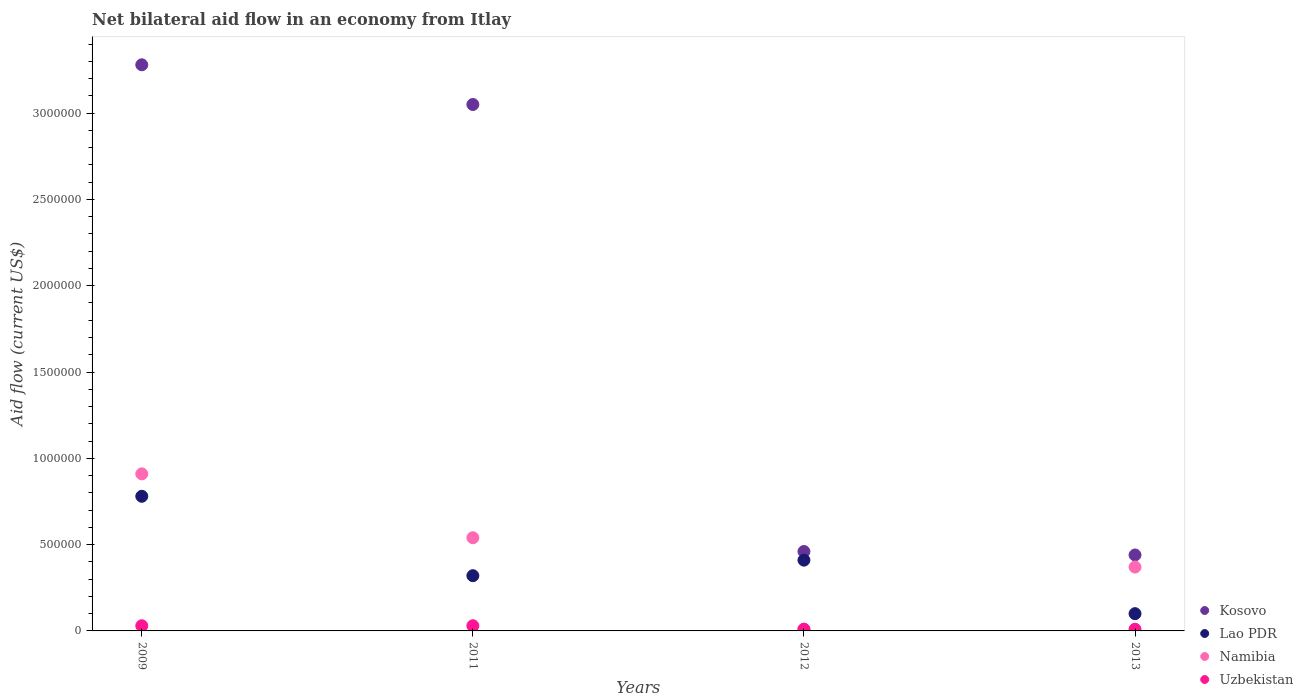How many different coloured dotlines are there?
Make the answer very short. 4. What is the net bilateral aid flow in Kosovo in 2011?
Your answer should be compact. 3.05e+06. Across all years, what is the maximum net bilateral aid flow in Namibia?
Give a very brief answer. 9.10e+05. Across all years, what is the minimum net bilateral aid flow in Namibia?
Provide a short and direct response. 10000. What is the total net bilateral aid flow in Lao PDR in the graph?
Make the answer very short. 1.61e+06. What is the difference between the net bilateral aid flow in Uzbekistan in 2009 and that in 2011?
Offer a very short reply. 0. What is the average net bilateral aid flow in Kosovo per year?
Provide a succinct answer. 1.81e+06. In the year 2013, what is the difference between the net bilateral aid flow in Lao PDR and net bilateral aid flow in Kosovo?
Offer a very short reply. -3.40e+05. What is the ratio of the net bilateral aid flow in Lao PDR in 2009 to that in 2013?
Your answer should be very brief. 7.8. What is the difference between the highest and the second highest net bilateral aid flow in Lao PDR?
Provide a succinct answer. 3.70e+05. What is the difference between the highest and the lowest net bilateral aid flow in Lao PDR?
Ensure brevity in your answer.  6.80e+05. In how many years, is the net bilateral aid flow in Kosovo greater than the average net bilateral aid flow in Kosovo taken over all years?
Make the answer very short. 2. Is the sum of the net bilateral aid flow in Lao PDR in 2011 and 2012 greater than the maximum net bilateral aid flow in Kosovo across all years?
Give a very brief answer. No. Is it the case that in every year, the sum of the net bilateral aid flow in Uzbekistan and net bilateral aid flow in Kosovo  is greater than the net bilateral aid flow in Namibia?
Offer a very short reply. Yes. Is the net bilateral aid flow in Namibia strictly greater than the net bilateral aid flow in Kosovo over the years?
Your answer should be very brief. No. Is the net bilateral aid flow in Kosovo strictly less than the net bilateral aid flow in Uzbekistan over the years?
Your answer should be compact. No. What is the difference between two consecutive major ticks on the Y-axis?
Your answer should be compact. 5.00e+05. Does the graph contain grids?
Ensure brevity in your answer.  No. What is the title of the graph?
Your answer should be very brief. Net bilateral aid flow in an economy from Itlay. Does "Qatar" appear as one of the legend labels in the graph?
Your answer should be compact. No. What is the label or title of the X-axis?
Offer a very short reply. Years. What is the label or title of the Y-axis?
Provide a succinct answer. Aid flow (current US$). What is the Aid flow (current US$) in Kosovo in 2009?
Your response must be concise. 3.28e+06. What is the Aid flow (current US$) of Lao PDR in 2009?
Offer a terse response. 7.80e+05. What is the Aid flow (current US$) of Namibia in 2009?
Provide a short and direct response. 9.10e+05. What is the Aid flow (current US$) of Kosovo in 2011?
Make the answer very short. 3.05e+06. What is the Aid flow (current US$) in Namibia in 2011?
Make the answer very short. 5.40e+05. What is the Aid flow (current US$) of Kosovo in 2012?
Give a very brief answer. 4.60e+05. What is the Aid flow (current US$) in Lao PDR in 2013?
Your answer should be compact. 1.00e+05. What is the Aid flow (current US$) in Namibia in 2013?
Provide a short and direct response. 3.70e+05. What is the Aid flow (current US$) of Uzbekistan in 2013?
Provide a short and direct response. 10000. Across all years, what is the maximum Aid flow (current US$) in Kosovo?
Ensure brevity in your answer.  3.28e+06. Across all years, what is the maximum Aid flow (current US$) in Lao PDR?
Make the answer very short. 7.80e+05. Across all years, what is the maximum Aid flow (current US$) in Namibia?
Ensure brevity in your answer.  9.10e+05. Across all years, what is the minimum Aid flow (current US$) of Lao PDR?
Make the answer very short. 1.00e+05. Across all years, what is the minimum Aid flow (current US$) in Namibia?
Make the answer very short. 10000. Across all years, what is the minimum Aid flow (current US$) in Uzbekistan?
Ensure brevity in your answer.  10000. What is the total Aid flow (current US$) in Kosovo in the graph?
Make the answer very short. 7.23e+06. What is the total Aid flow (current US$) of Lao PDR in the graph?
Offer a terse response. 1.61e+06. What is the total Aid flow (current US$) of Namibia in the graph?
Make the answer very short. 1.83e+06. What is the difference between the Aid flow (current US$) of Kosovo in 2009 and that in 2011?
Keep it short and to the point. 2.30e+05. What is the difference between the Aid flow (current US$) of Lao PDR in 2009 and that in 2011?
Your response must be concise. 4.60e+05. What is the difference between the Aid flow (current US$) of Kosovo in 2009 and that in 2012?
Give a very brief answer. 2.82e+06. What is the difference between the Aid flow (current US$) in Namibia in 2009 and that in 2012?
Offer a terse response. 9.00e+05. What is the difference between the Aid flow (current US$) in Kosovo in 2009 and that in 2013?
Your answer should be compact. 2.84e+06. What is the difference between the Aid flow (current US$) of Lao PDR in 2009 and that in 2013?
Make the answer very short. 6.80e+05. What is the difference between the Aid flow (current US$) in Namibia in 2009 and that in 2013?
Keep it short and to the point. 5.40e+05. What is the difference between the Aid flow (current US$) in Uzbekistan in 2009 and that in 2013?
Offer a terse response. 2.00e+04. What is the difference between the Aid flow (current US$) of Kosovo in 2011 and that in 2012?
Ensure brevity in your answer.  2.59e+06. What is the difference between the Aid flow (current US$) in Namibia in 2011 and that in 2012?
Provide a succinct answer. 5.30e+05. What is the difference between the Aid flow (current US$) of Kosovo in 2011 and that in 2013?
Provide a succinct answer. 2.61e+06. What is the difference between the Aid flow (current US$) in Namibia in 2012 and that in 2013?
Make the answer very short. -3.60e+05. What is the difference between the Aid flow (current US$) in Uzbekistan in 2012 and that in 2013?
Ensure brevity in your answer.  0. What is the difference between the Aid flow (current US$) of Kosovo in 2009 and the Aid flow (current US$) of Lao PDR in 2011?
Provide a succinct answer. 2.96e+06. What is the difference between the Aid flow (current US$) in Kosovo in 2009 and the Aid flow (current US$) in Namibia in 2011?
Provide a short and direct response. 2.74e+06. What is the difference between the Aid flow (current US$) in Kosovo in 2009 and the Aid flow (current US$) in Uzbekistan in 2011?
Offer a terse response. 3.25e+06. What is the difference between the Aid flow (current US$) of Lao PDR in 2009 and the Aid flow (current US$) of Namibia in 2011?
Give a very brief answer. 2.40e+05. What is the difference between the Aid flow (current US$) of Lao PDR in 2009 and the Aid flow (current US$) of Uzbekistan in 2011?
Give a very brief answer. 7.50e+05. What is the difference between the Aid flow (current US$) in Namibia in 2009 and the Aid flow (current US$) in Uzbekistan in 2011?
Provide a succinct answer. 8.80e+05. What is the difference between the Aid flow (current US$) of Kosovo in 2009 and the Aid flow (current US$) of Lao PDR in 2012?
Offer a very short reply. 2.87e+06. What is the difference between the Aid flow (current US$) in Kosovo in 2009 and the Aid flow (current US$) in Namibia in 2012?
Make the answer very short. 3.27e+06. What is the difference between the Aid flow (current US$) in Kosovo in 2009 and the Aid flow (current US$) in Uzbekistan in 2012?
Your answer should be very brief. 3.27e+06. What is the difference between the Aid flow (current US$) in Lao PDR in 2009 and the Aid flow (current US$) in Namibia in 2012?
Your answer should be very brief. 7.70e+05. What is the difference between the Aid flow (current US$) of Lao PDR in 2009 and the Aid flow (current US$) of Uzbekistan in 2012?
Give a very brief answer. 7.70e+05. What is the difference between the Aid flow (current US$) of Namibia in 2009 and the Aid flow (current US$) of Uzbekistan in 2012?
Provide a succinct answer. 9.00e+05. What is the difference between the Aid flow (current US$) of Kosovo in 2009 and the Aid flow (current US$) of Lao PDR in 2013?
Offer a terse response. 3.18e+06. What is the difference between the Aid flow (current US$) of Kosovo in 2009 and the Aid flow (current US$) of Namibia in 2013?
Your response must be concise. 2.91e+06. What is the difference between the Aid flow (current US$) of Kosovo in 2009 and the Aid flow (current US$) of Uzbekistan in 2013?
Provide a short and direct response. 3.27e+06. What is the difference between the Aid flow (current US$) in Lao PDR in 2009 and the Aid flow (current US$) in Uzbekistan in 2013?
Provide a succinct answer. 7.70e+05. What is the difference between the Aid flow (current US$) of Namibia in 2009 and the Aid flow (current US$) of Uzbekistan in 2013?
Provide a succinct answer. 9.00e+05. What is the difference between the Aid flow (current US$) of Kosovo in 2011 and the Aid flow (current US$) of Lao PDR in 2012?
Offer a very short reply. 2.64e+06. What is the difference between the Aid flow (current US$) in Kosovo in 2011 and the Aid flow (current US$) in Namibia in 2012?
Your answer should be compact. 3.04e+06. What is the difference between the Aid flow (current US$) in Kosovo in 2011 and the Aid flow (current US$) in Uzbekistan in 2012?
Your response must be concise. 3.04e+06. What is the difference between the Aid flow (current US$) in Lao PDR in 2011 and the Aid flow (current US$) in Namibia in 2012?
Your answer should be very brief. 3.10e+05. What is the difference between the Aid flow (current US$) in Namibia in 2011 and the Aid flow (current US$) in Uzbekistan in 2012?
Your answer should be compact. 5.30e+05. What is the difference between the Aid flow (current US$) in Kosovo in 2011 and the Aid flow (current US$) in Lao PDR in 2013?
Offer a very short reply. 2.95e+06. What is the difference between the Aid flow (current US$) in Kosovo in 2011 and the Aid flow (current US$) in Namibia in 2013?
Offer a terse response. 2.68e+06. What is the difference between the Aid flow (current US$) of Kosovo in 2011 and the Aid flow (current US$) of Uzbekistan in 2013?
Your response must be concise. 3.04e+06. What is the difference between the Aid flow (current US$) of Lao PDR in 2011 and the Aid flow (current US$) of Uzbekistan in 2013?
Your response must be concise. 3.10e+05. What is the difference between the Aid flow (current US$) of Namibia in 2011 and the Aid flow (current US$) of Uzbekistan in 2013?
Give a very brief answer. 5.30e+05. What is the difference between the Aid flow (current US$) of Kosovo in 2012 and the Aid flow (current US$) of Namibia in 2013?
Provide a short and direct response. 9.00e+04. What is the average Aid flow (current US$) in Kosovo per year?
Offer a terse response. 1.81e+06. What is the average Aid flow (current US$) of Lao PDR per year?
Your response must be concise. 4.02e+05. What is the average Aid flow (current US$) in Namibia per year?
Provide a short and direct response. 4.58e+05. In the year 2009, what is the difference between the Aid flow (current US$) in Kosovo and Aid flow (current US$) in Lao PDR?
Give a very brief answer. 2.50e+06. In the year 2009, what is the difference between the Aid flow (current US$) in Kosovo and Aid flow (current US$) in Namibia?
Provide a short and direct response. 2.37e+06. In the year 2009, what is the difference between the Aid flow (current US$) of Kosovo and Aid flow (current US$) of Uzbekistan?
Provide a succinct answer. 3.25e+06. In the year 2009, what is the difference between the Aid flow (current US$) of Lao PDR and Aid flow (current US$) of Namibia?
Your response must be concise. -1.30e+05. In the year 2009, what is the difference between the Aid flow (current US$) in Lao PDR and Aid flow (current US$) in Uzbekistan?
Keep it short and to the point. 7.50e+05. In the year 2009, what is the difference between the Aid flow (current US$) in Namibia and Aid flow (current US$) in Uzbekistan?
Your response must be concise. 8.80e+05. In the year 2011, what is the difference between the Aid flow (current US$) of Kosovo and Aid flow (current US$) of Lao PDR?
Your response must be concise. 2.73e+06. In the year 2011, what is the difference between the Aid flow (current US$) of Kosovo and Aid flow (current US$) of Namibia?
Provide a short and direct response. 2.51e+06. In the year 2011, what is the difference between the Aid flow (current US$) in Kosovo and Aid flow (current US$) in Uzbekistan?
Give a very brief answer. 3.02e+06. In the year 2011, what is the difference between the Aid flow (current US$) of Lao PDR and Aid flow (current US$) of Uzbekistan?
Give a very brief answer. 2.90e+05. In the year 2011, what is the difference between the Aid flow (current US$) of Namibia and Aid flow (current US$) of Uzbekistan?
Ensure brevity in your answer.  5.10e+05. In the year 2012, what is the difference between the Aid flow (current US$) of Kosovo and Aid flow (current US$) of Lao PDR?
Your answer should be very brief. 5.00e+04. In the year 2012, what is the difference between the Aid flow (current US$) in Kosovo and Aid flow (current US$) in Uzbekistan?
Offer a terse response. 4.50e+05. In the year 2012, what is the difference between the Aid flow (current US$) of Lao PDR and Aid flow (current US$) of Namibia?
Offer a very short reply. 4.00e+05. In the year 2013, what is the difference between the Aid flow (current US$) in Kosovo and Aid flow (current US$) in Namibia?
Your response must be concise. 7.00e+04. In the year 2013, what is the difference between the Aid flow (current US$) in Lao PDR and Aid flow (current US$) in Namibia?
Provide a succinct answer. -2.70e+05. In the year 2013, what is the difference between the Aid flow (current US$) of Lao PDR and Aid flow (current US$) of Uzbekistan?
Keep it short and to the point. 9.00e+04. In the year 2013, what is the difference between the Aid flow (current US$) in Namibia and Aid flow (current US$) in Uzbekistan?
Give a very brief answer. 3.60e+05. What is the ratio of the Aid flow (current US$) of Kosovo in 2009 to that in 2011?
Make the answer very short. 1.08. What is the ratio of the Aid flow (current US$) of Lao PDR in 2009 to that in 2011?
Provide a short and direct response. 2.44. What is the ratio of the Aid flow (current US$) of Namibia in 2009 to that in 2011?
Your answer should be compact. 1.69. What is the ratio of the Aid flow (current US$) in Kosovo in 2009 to that in 2012?
Your answer should be very brief. 7.13. What is the ratio of the Aid flow (current US$) in Lao PDR in 2009 to that in 2012?
Offer a very short reply. 1.9. What is the ratio of the Aid flow (current US$) in Namibia in 2009 to that in 2012?
Offer a terse response. 91. What is the ratio of the Aid flow (current US$) of Uzbekistan in 2009 to that in 2012?
Ensure brevity in your answer.  3. What is the ratio of the Aid flow (current US$) in Kosovo in 2009 to that in 2013?
Give a very brief answer. 7.45. What is the ratio of the Aid flow (current US$) in Namibia in 2009 to that in 2013?
Offer a very short reply. 2.46. What is the ratio of the Aid flow (current US$) in Kosovo in 2011 to that in 2012?
Offer a very short reply. 6.63. What is the ratio of the Aid flow (current US$) of Lao PDR in 2011 to that in 2012?
Your response must be concise. 0.78. What is the ratio of the Aid flow (current US$) in Kosovo in 2011 to that in 2013?
Provide a succinct answer. 6.93. What is the ratio of the Aid flow (current US$) in Lao PDR in 2011 to that in 2013?
Keep it short and to the point. 3.2. What is the ratio of the Aid flow (current US$) in Namibia in 2011 to that in 2013?
Ensure brevity in your answer.  1.46. What is the ratio of the Aid flow (current US$) in Uzbekistan in 2011 to that in 2013?
Your answer should be very brief. 3. What is the ratio of the Aid flow (current US$) of Kosovo in 2012 to that in 2013?
Your answer should be compact. 1.05. What is the ratio of the Aid flow (current US$) of Lao PDR in 2012 to that in 2013?
Provide a short and direct response. 4.1. What is the ratio of the Aid flow (current US$) in Namibia in 2012 to that in 2013?
Your answer should be very brief. 0.03. What is the difference between the highest and the second highest Aid flow (current US$) in Kosovo?
Your answer should be compact. 2.30e+05. What is the difference between the highest and the second highest Aid flow (current US$) of Namibia?
Make the answer very short. 3.70e+05. What is the difference between the highest and the lowest Aid flow (current US$) in Kosovo?
Offer a very short reply. 2.84e+06. What is the difference between the highest and the lowest Aid flow (current US$) in Lao PDR?
Make the answer very short. 6.80e+05. What is the difference between the highest and the lowest Aid flow (current US$) in Namibia?
Keep it short and to the point. 9.00e+05. What is the difference between the highest and the lowest Aid flow (current US$) in Uzbekistan?
Ensure brevity in your answer.  2.00e+04. 